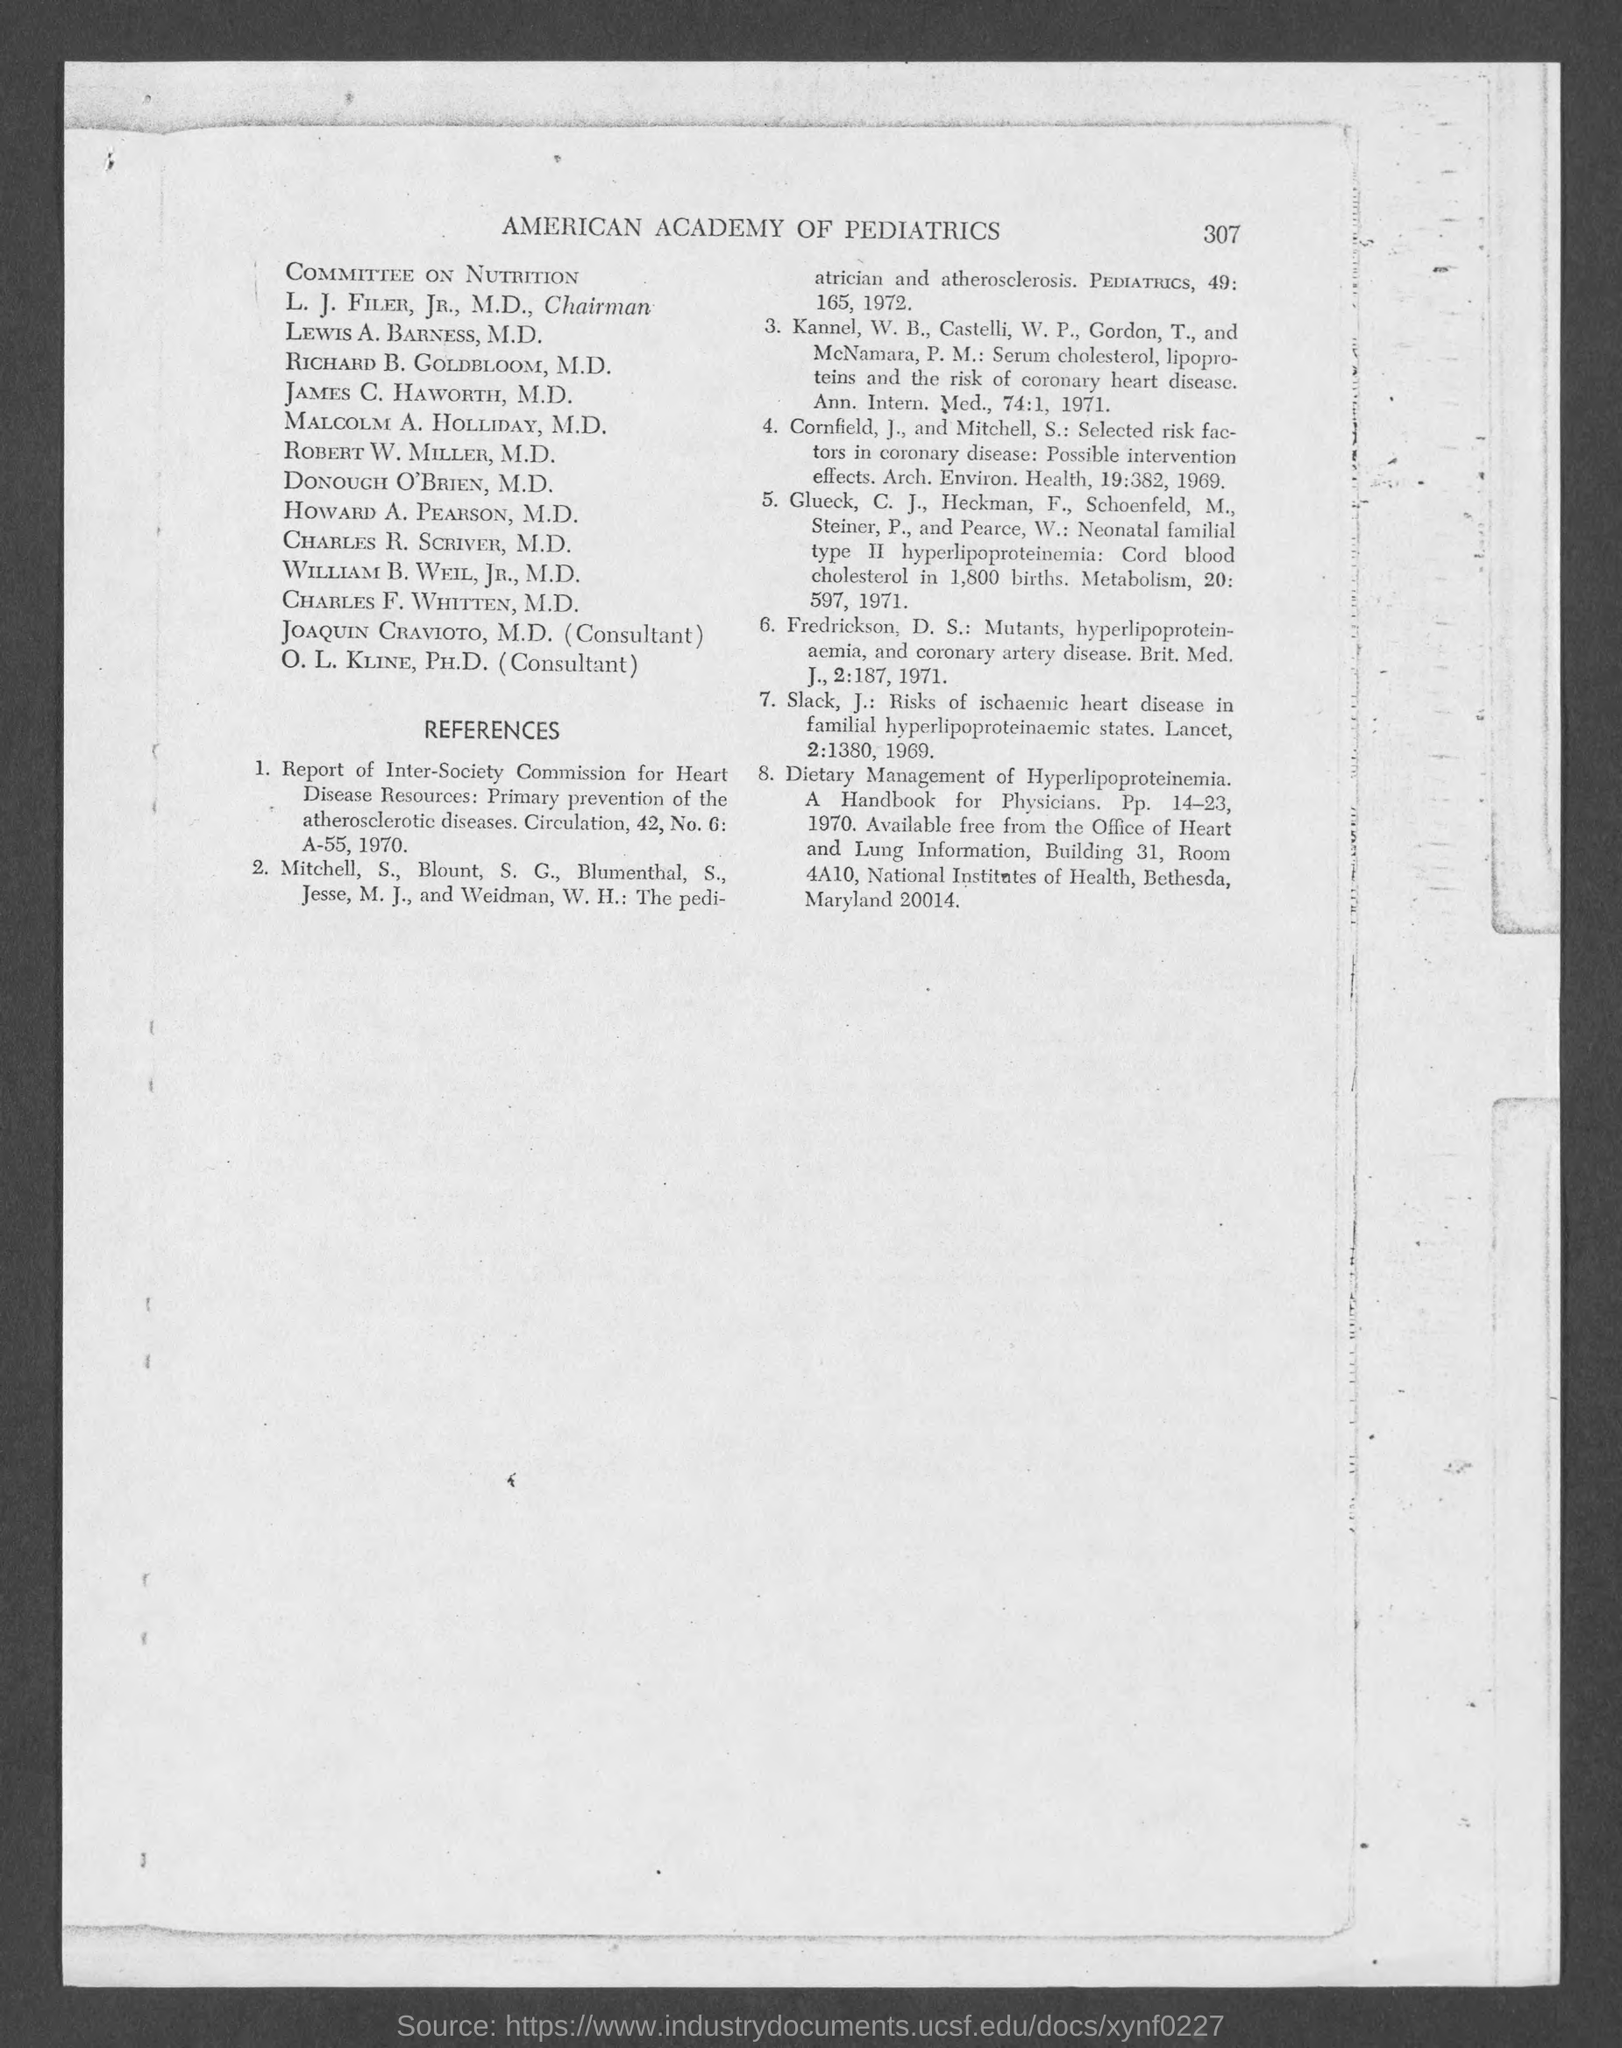What is the page number at top of the page?
Keep it short and to the point. 307. 